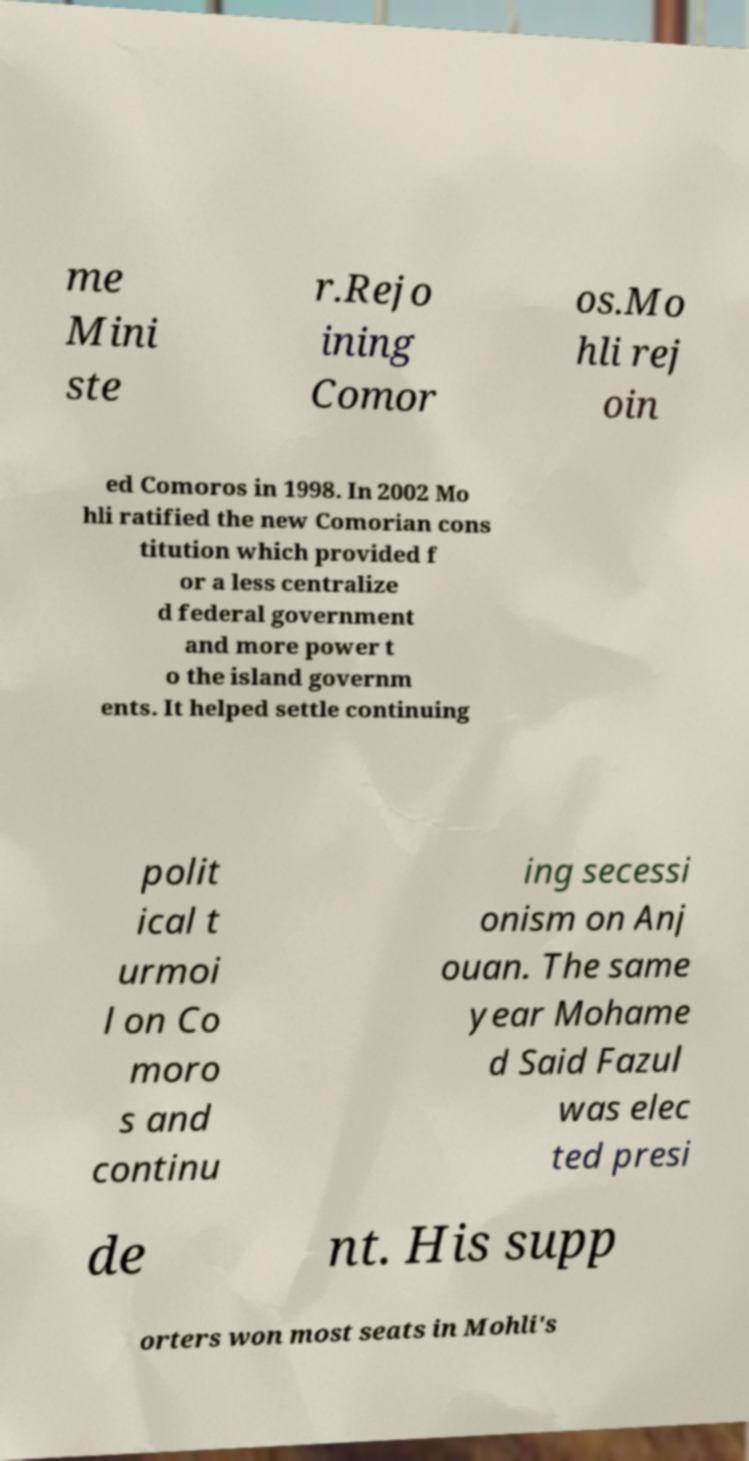There's text embedded in this image that I need extracted. Can you transcribe it verbatim? me Mini ste r.Rejo ining Comor os.Mo hli rej oin ed Comoros in 1998. In 2002 Mo hli ratified the new Comorian cons titution which provided f or a less centralize d federal government and more power t o the island governm ents. It helped settle continuing polit ical t urmoi l on Co moro s and continu ing secessi onism on Anj ouan. The same year Mohame d Said Fazul was elec ted presi de nt. His supp orters won most seats in Mohli's 